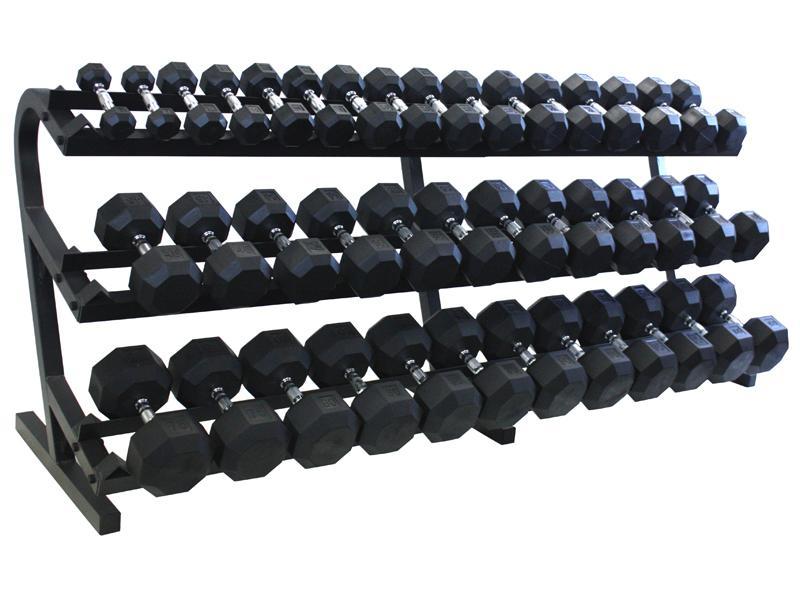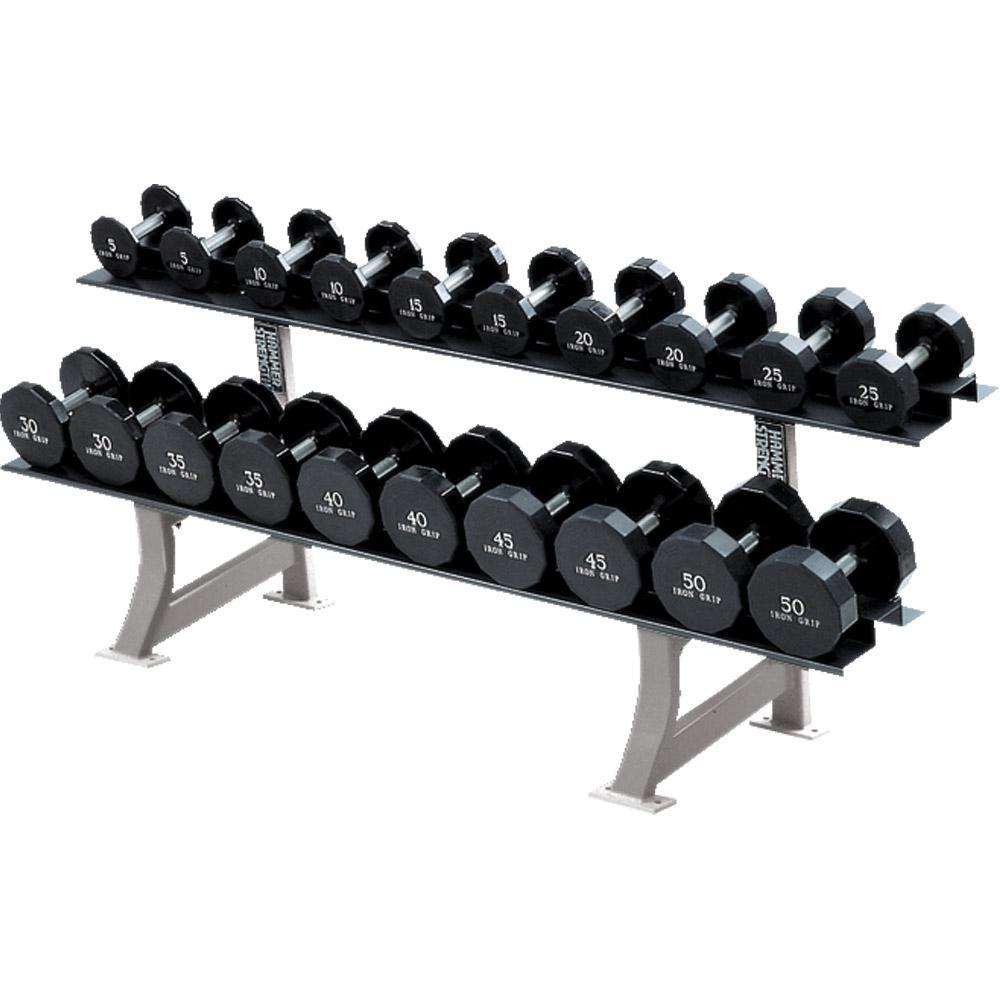The first image is the image on the left, the second image is the image on the right. For the images displayed, is the sentence "Right image shows a weight rack with exactly two horizontal rows of dumbbells." factually correct? Answer yes or no. Yes. 